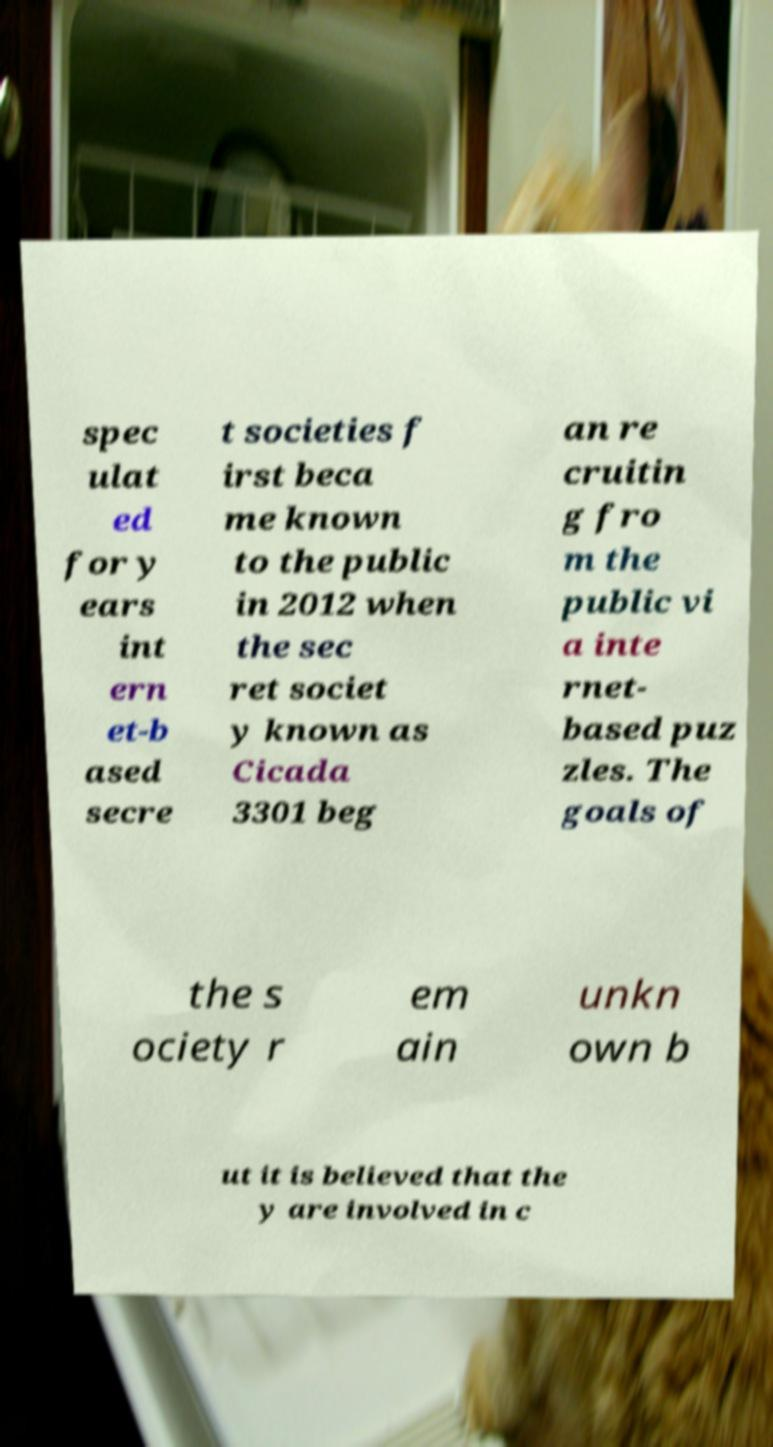What messages or text are displayed in this image? I need them in a readable, typed format. spec ulat ed for y ears int ern et-b ased secre t societies f irst beca me known to the public in 2012 when the sec ret societ y known as Cicada 3301 beg an re cruitin g fro m the public vi a inte rnet- based puz zles. The goals of the s ociety r em ain unkn own b ut it is believed that the y are involved in c 